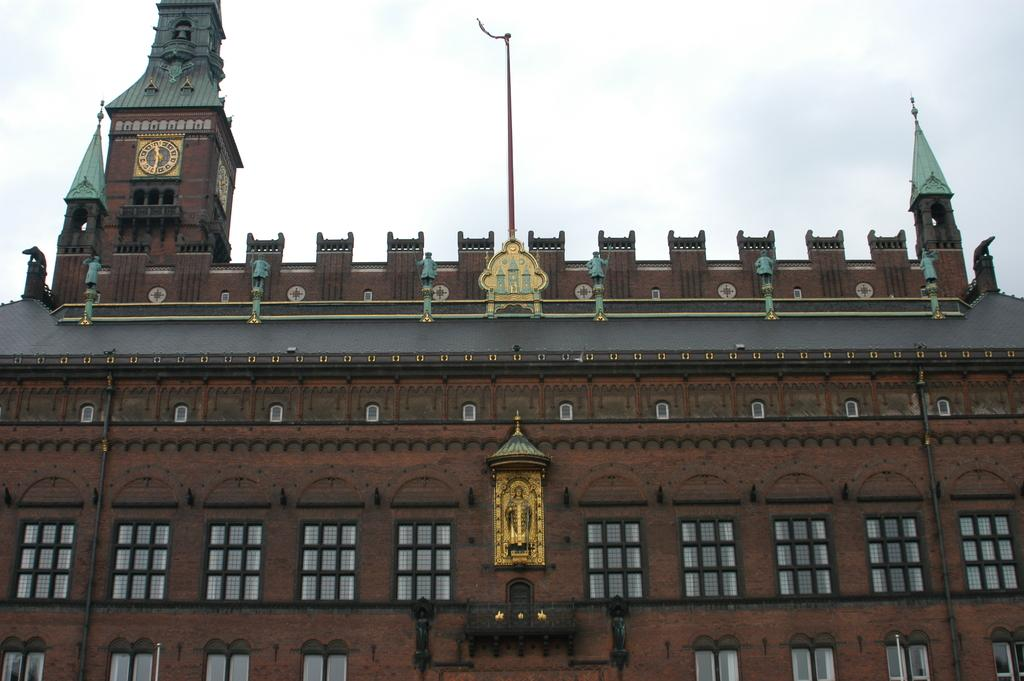What type of structure is present in the image? There is a building in the image. What can be seen in the background of the image? The sky is visible in the background of the image. What type of whistle does the sister of the minister use in the image? There is no mention of a minister, sister, or whistle in the image, so this question cannot be answered. 